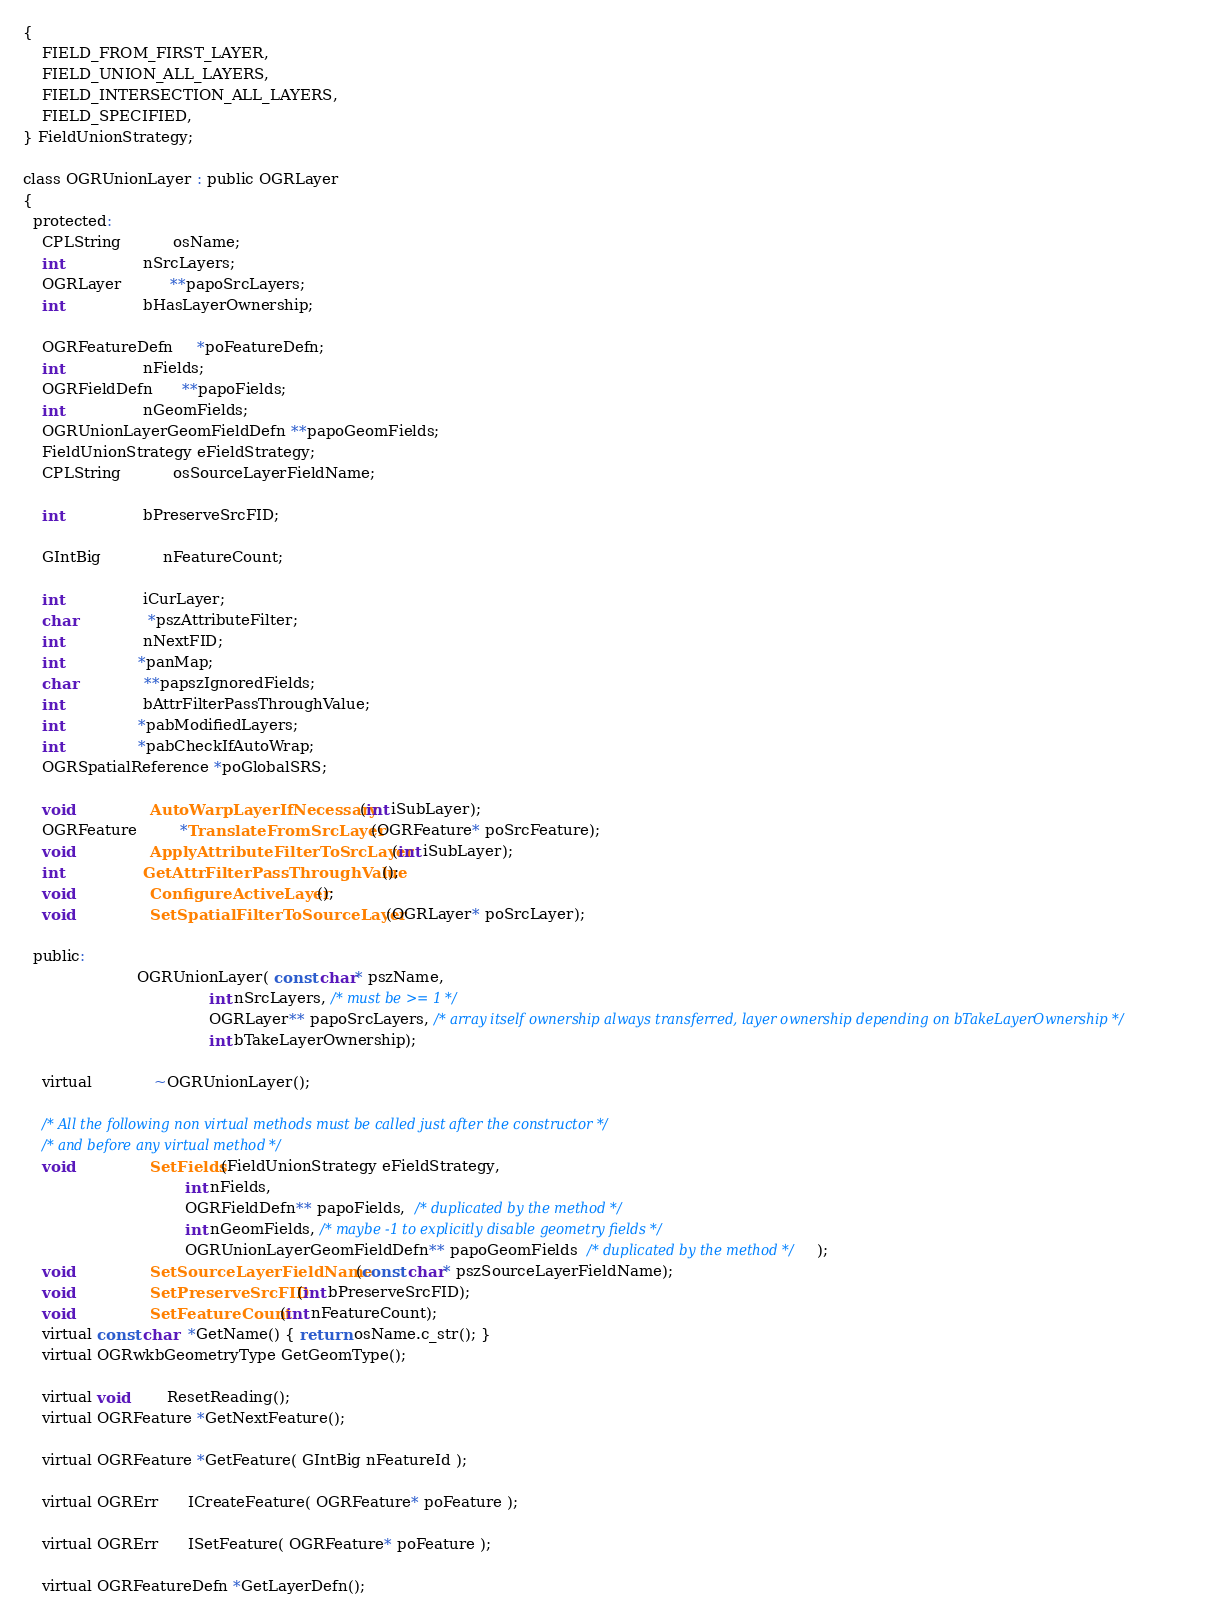<code> <loc_0><loc_0><loc_500><loc_500><_C_>{
    FIELD_FROM_FIRST_LAYER,
    FIELD_UNION_ALL_LAYERS,
    FIELD_INTERSECTION_ALL_LAYERS,
    FIELD_SPECIFIED,
} FieldUnionStrategy;

class OGRUnionLayer : public OGRLayer
{
  protected:
    CPLString           osName;
    int                 nSrcLayers;
    OGRLayer          **papoSrcLayers;
    int                 bHasLayerOwnership;

    OGRFeatureDefn     *poFeatureDefn;
    int                 nFields;
    OGRFieldDefn      **papoFields;
    int                 nGeomFields;
    OGRUnionLayerGeomFieldDefn **papoGeomFields;
    FieldUnionStrategy eFieldStrategy;
    CPLString           osSourceLayerFieldName;

    int                 bPreserveSrcFID;

    GIntBig             nFeatureCount;

    int                 iCurLayer;
    char               *pszAttributeFilter;
    int                 nNextFID;
    int                *panMap;
    char              **papszIgnoredFields;
    int                 bAttrFilterPassThroughValue;
    int                *pabModifiedLayers;
    int                *pabCheckIfAutoWrap;
    OGRSpatialReference *poGlobalSRS;

    void                AutoWarpLayerIfNecessary(int iSubLayer);
    OGRFeature         *TranslateFromSrcLayer(OGRFeature* poSrcFeature);
    void                ApplyAttributeFilterToSrcLayer(int iSubLayer);
    int                 GetAttrFilterPassThroughValue();
    void                ConfigureActiveLayer();
    void                SetSpatialFilterToSourceLayer(OGRLayer* poSrcLayer);

  public:
                        OGRUnionLayer( const char* pszName,
                                       int nSrcLayers, /* must be >= 1 */
                                       OGRLayer** papoSrcLayers, /* array itself ownership always transferred, layer ownership depending on bTakeLayerOwnership */
                                       int bTakeLayerOwnership);

    virtual             ~OGRUnionLayer();

    /* All the following non virtual methods must be called just after the constructor */
    /* and before any virtual method */
    void                SetFields(FieldUnionStrategy eFieldStrategy,
                                  int nFields,
                                  OGRFieldDefn** papoFields,  /* duplicated by the method */
                                  int nGeomFields, /* maybe -1 to explicitly disable geometry fields */
                                  OGRUnionLayerGeomFieldDefn** papoGeomFields  /* duplicated by the method */);
    void                SetSourceLayerFieldName(const char* pszSourceLayerFieldName);
    void                SetPreserveSrcFID(int bPreserveSrcFID);
    void                SetFeatureCount(int nFeatureCount);
    virtual const char  *GetName() { return osName.c_str(); }
    virtual OGRwkbGeometryType GetGeomType();

    virtual void        ResetReading();
    virtual OGRFeature *GetNextFeature();

    virtual OGRFeature *GetFeature( GIntBig nFeatureId );

    virtual OGRErr      ICreateFeature( OGRFeature* poFeature );

    virtual OGRErr      ISetFeature( OGRFeature* poFeature );

    virtual OGRFeatureDefn *GetLayerDefn();
</code> 